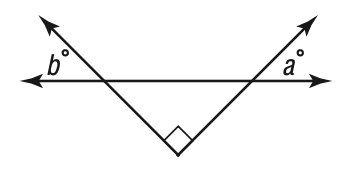Answer the mathemtical geometry problem and directly provide the correct option letter.
Question: Which of the following statements about the figure is true?
Choices: A: 90 > a + b B: a + b = 90 C: a + b > 90 D: a > b B 